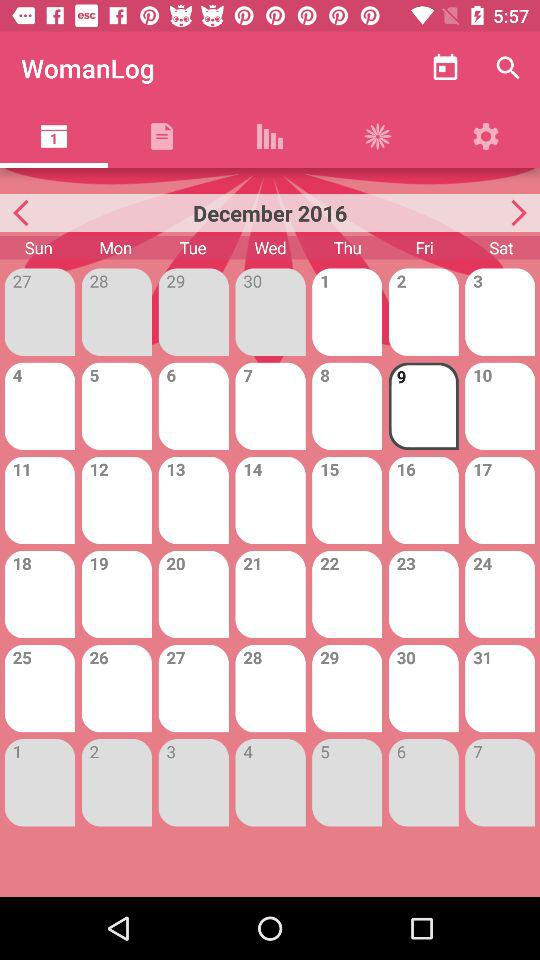What is the selected date? The selected date is Friday, December 9, 2016. 